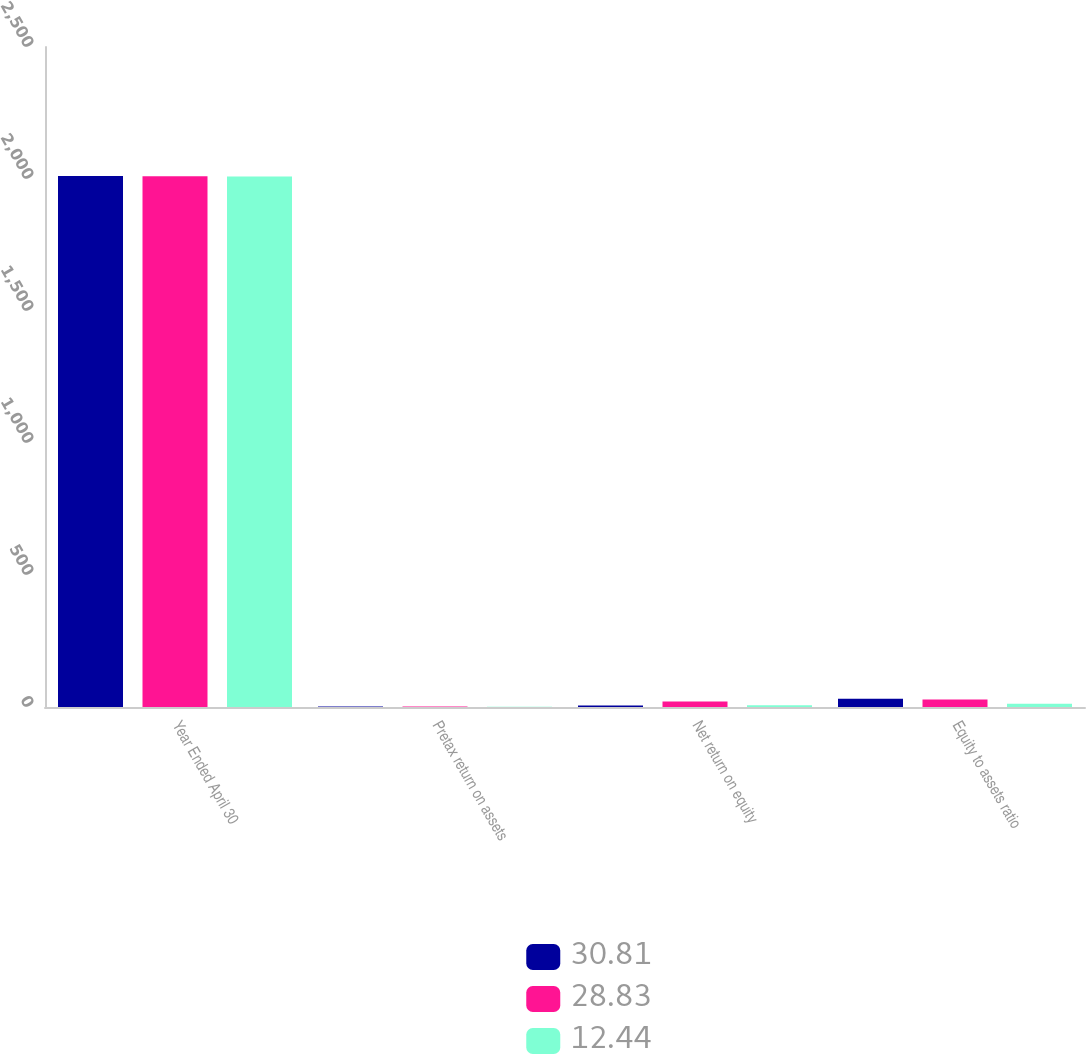Convert chart to OTSL. <chart><loc_0><loc_0><loc_500><loc_500><stacked_bar_chart><ecel><fcel>Year Ended April 30<fcel>Pretax return on assets<fcel>Net return on equity<fcel>Equity to assets ratio<nl><fcel>30.81<fcel>2011<fcel>2.36<fcel>5.43<fcel>30.81<nl><fcel>28.83<fcel>2010<fcel>2.12<fcel>21.04<fcel>28.83<nl><fcel>12.44<fcel>2009<fcel>1.03<fcel>6.67<fcel>12.44<nl></chart> 